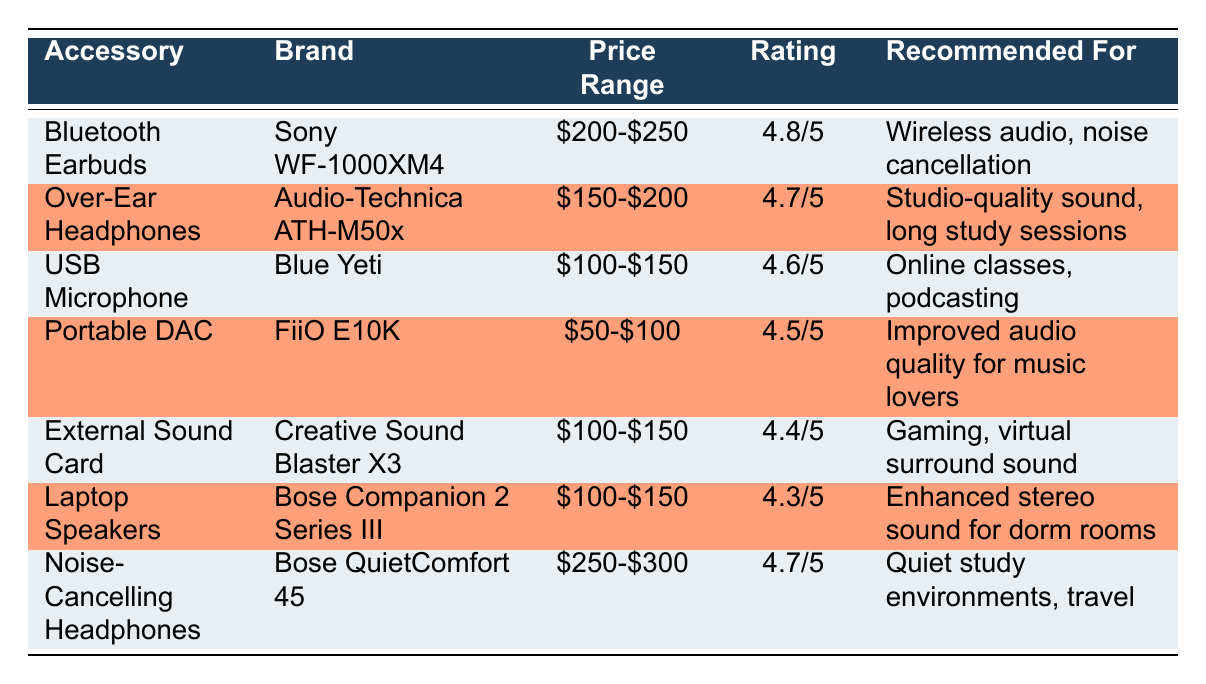What is the price range of the Bluetooth Earbuds? The table shows the "Price Range" for the "Bluetooth Earbuds," which is listed as "$200-$250."
Answer: $200-$250 Which accessory has the highest rating? The highest rating in the table is "4.8/5," which belongs to the "Bluetooth Earbuds."
Answer: Bluetooth Earbuds Are the Bose QuietComfort 45 headphones recommended for gaming? According to the table, the "Bose QuietComfort 45" is recommended for "Quiet study environments, travel," which does not include gaming.
Answer: No What is the average rating of the listed accessories? The ratings are: 4.8, 4.7, 4.6, 4.5, 4.4, 4.3, and 4.7. The sum is 4.8 + 4.7 + 4.6 + 4.5 + 4.4 + 4.3 + 4.7 = 28, and there are 7 ratings, so the average rating is 28/7 = 4.0.
Answer: 4.0 Which accessory is recommended for online classes? The table specifies that the "USB Microphone" is recommended for "Online classes, podcasting," directly answering the inquiry.
Answer: USB Microphone Are the laptop speakers more expensive than the FiiO E10K Portable DAC? The "Laptop Speakers" are in the price range of "$100-$150," while the "Portable DAC" has a price range of "$50-$100." Since $100-$150 is higher than $50-$100, this statement is true.
Answer: Yes Which accessory is the least expensive according to the price ranges provided? The "Portable DAC" is priced at "$50-$100," which is the lowest price range listed when compared to others.
Answer: Portable DAC How many accessories have a rating of 4.6 or higher? The accessories with ratings of 4.6 or above are: Bluetooth Earbuds (4.8), Over-Ear Headphones (4.7), USB Microphone (4.6), Noise-Cancelling Headphones (4.7), totaling to four accessories.
Answer: 4 